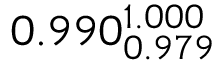<formula> <loc_0><loc_0><loc_500><loc_500>0 . 9 9 0 _ { 0 . 9 7 9 } ^ { 1 . 0 0 0 }</formula> 